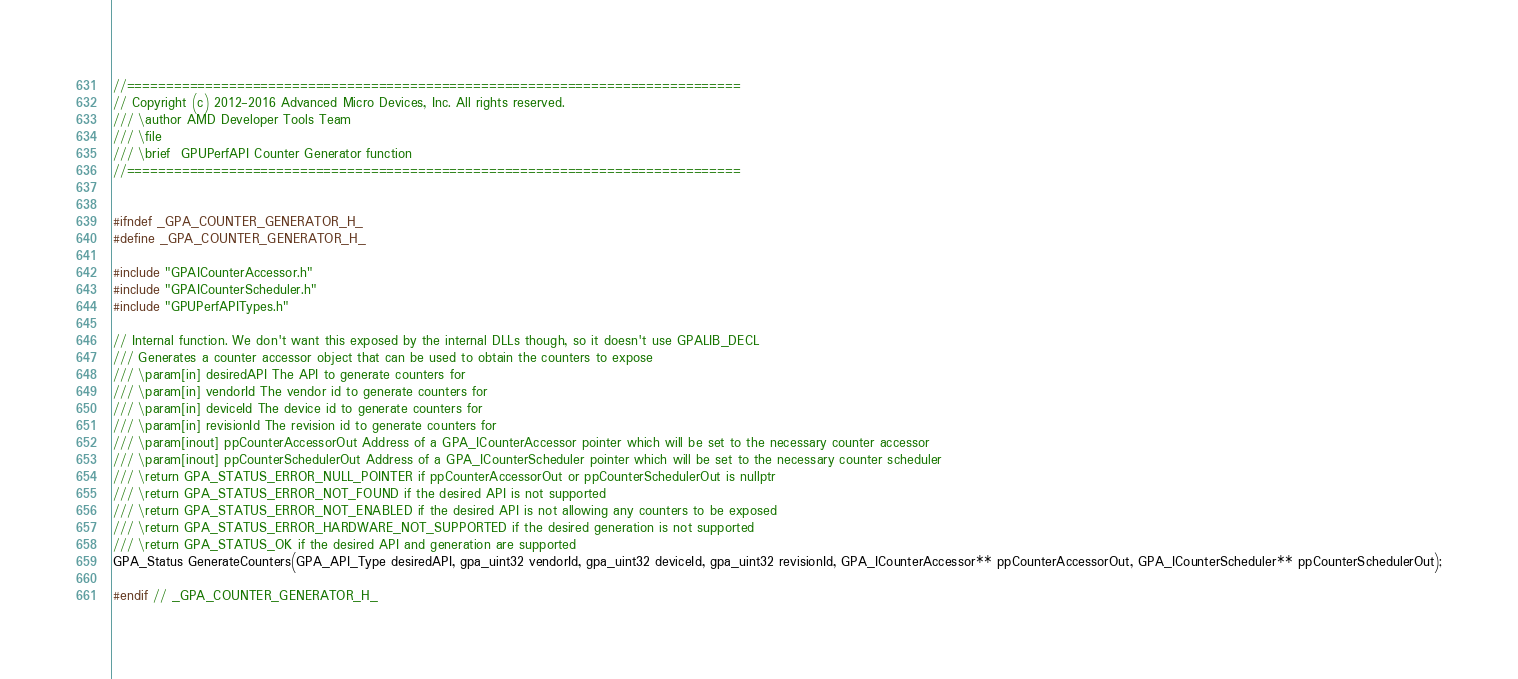Convert code to text. <code><loc_0><loc_0><loc_500><loc_500><_C_>//==============================================================================
// Copyright (c) 2012-2016 Advanced Micro Devices, Inc. All rights reserved.
/// \author AMD Developer Tools Team
/// \file
/// \brief  GPUPerfAPI Counter Generator function
//==============================================================================


#ifndef _GPA_COUNTER_GENERATOR_H_
#define _GPA_COUNTER_GENERATOR_H_

#include "GPAICounterAccessor.h"
#include "GPAICounterScheduler.h"
#include "GPUPerfAPITypes.h"

// Internal function. We don't want this exposed by the internal DLLs though, so it doesn't use GPALIB_DECL
/// Generates a counter accessor object that can be used to obtain the counters to expose
/// \param[in] desiredAPI The API to generate counters for
/// \param[in] vendorId The vendor id to generate counters for
/// \param[in] deviceId The device id to generate counters for
/// \param[in] revisionId The revision id to generate counters for
/// \param[inout] ppCounterAccessorOut Address of a GPA_ICounterAccessor pointer which will be set to the necessary counter accessor
/// \param[inout] ppCounterSchedulerOut Address of a GPA_ICounterScheduler pointer which will be set to the necessary counter scheduler
/// \return GPA_STATUS_ERROR_NULL_POINTER if ppCounterAccessorOut or ppCounterSchedulerOut is nullptr
/// \return GPA_STATUS_ERROR_NOT_FOUND if the desired API is not supported
/// \return GPA_STATUS_ERROR_NOT_ENABLED if the desired API is not allowing any counters to be exposed
/// \return GPA_STATUS_ERROR_HARDWARE_NOT_SUPPORTED if the desired generation is not supported
/// \return GPA_STATUS_OK if the desired API and generation are supported
GPA_Status GenerateCounters(GPA_API_Type desiredAPI, gpa_uint32 vendorId, gpa_uint32 deviceId, gpa_uint32 revisionId, GPA_ICounterAccessor** ppCounterAccessorOut, GPA_ICounterScheduler** ppCounterSchedulerOut);

#endif // _GPA_COUNTER_GENERATOR_H_
</code> 